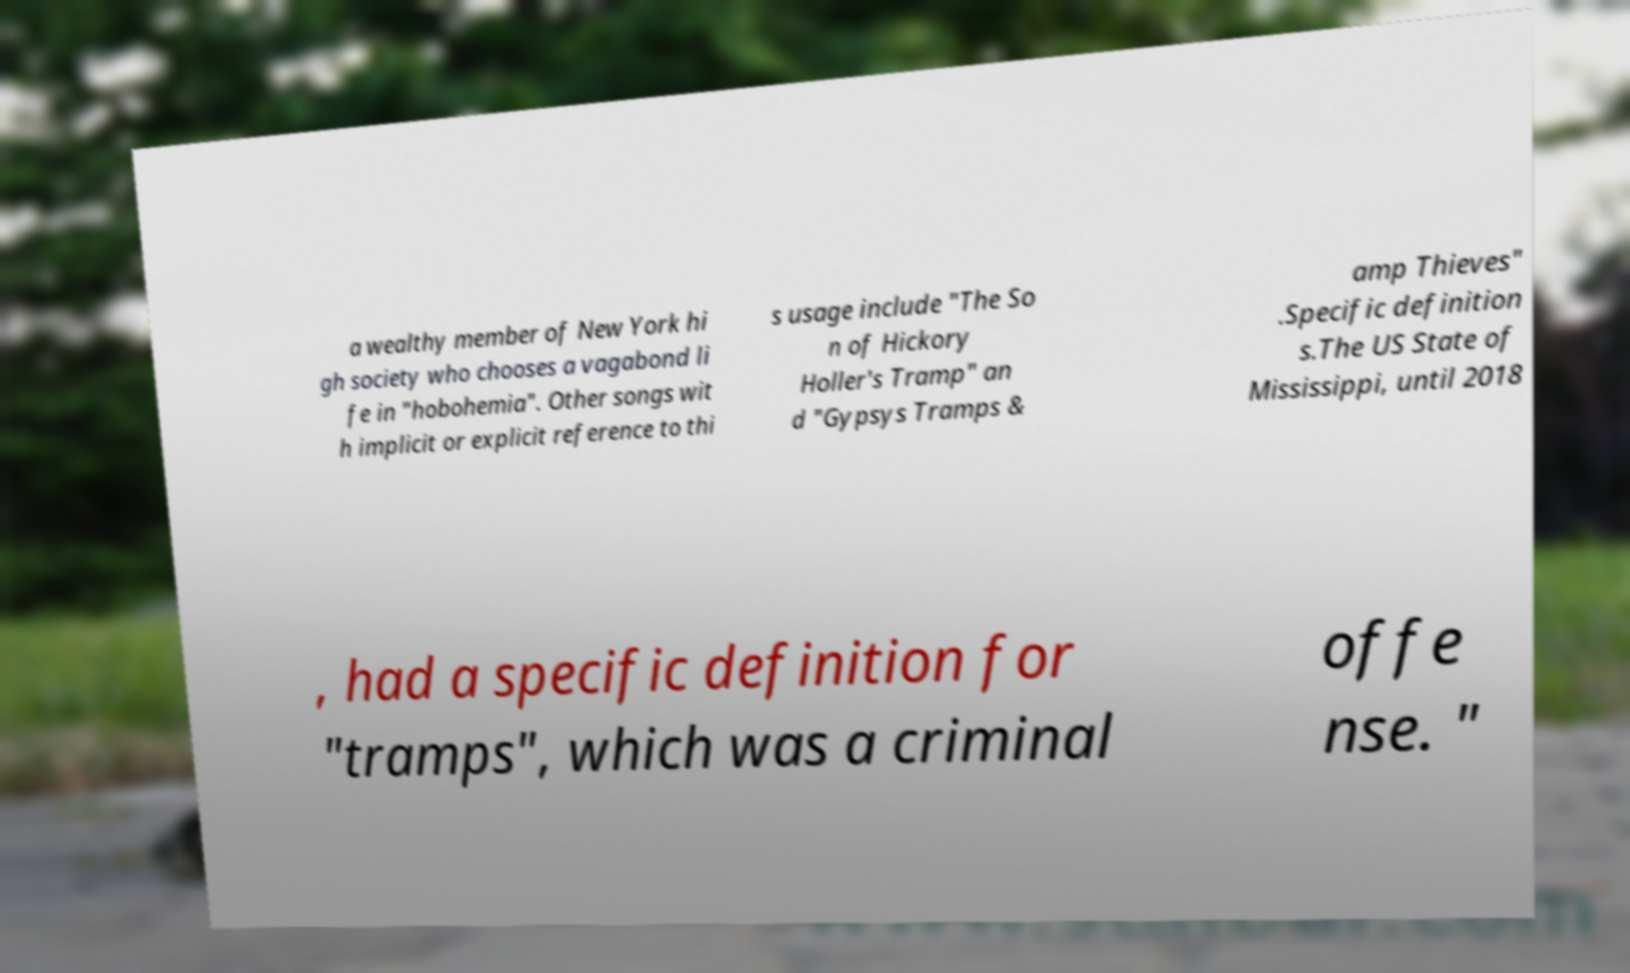Could you assist in decoding the text presented in this image and type it out clearly? a wealthy member of New York hi gh society who chooses a vagabond li fe in "hobohemia". Other songs wit h implicit or explicit reference to thi s usage include "The So n of Hickory Holler's Tramp" an d "Gypsys Tramps & amp Thieves" .Specific definition s.The US State of Mississippi, until 2018 , had a specific definition for "tramps", which was a criminal offe nse. " 